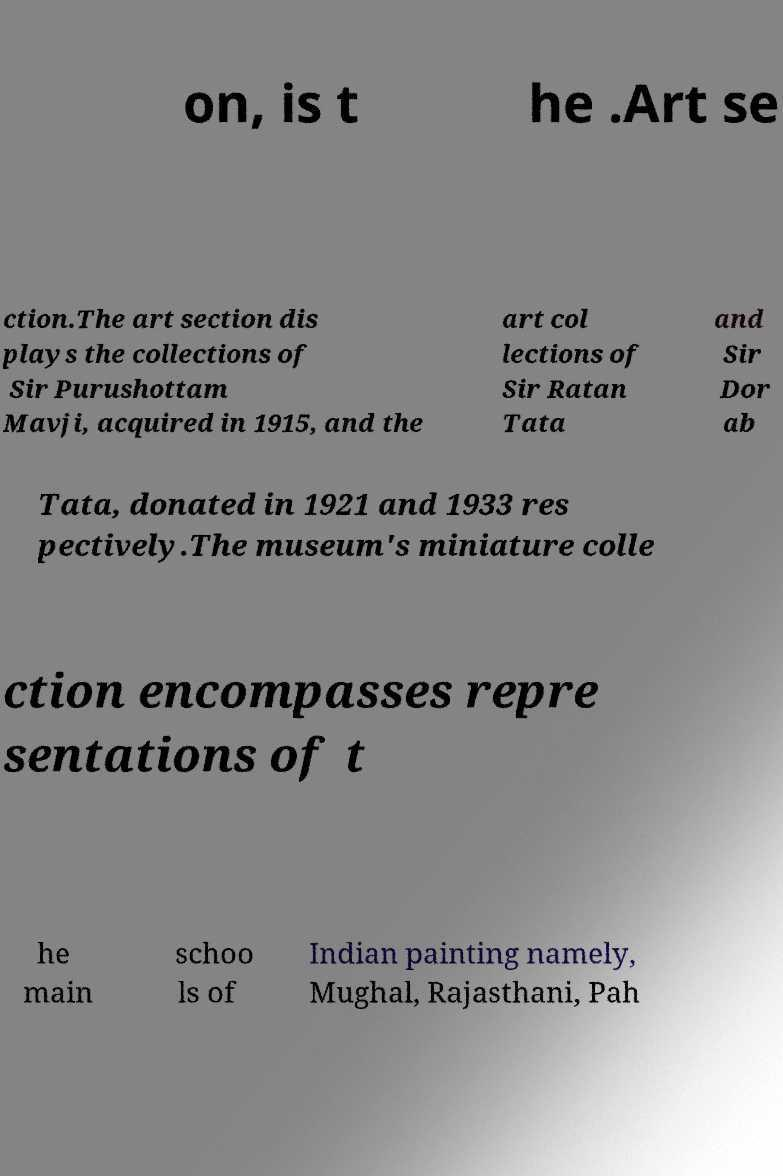Please identify and transcribe the text found in this image. on, is t he .Art se ction.The art section dis plays the collections of Sir Purushottam Mavji, acquired in 1915, and the art col lections of Sir Ratan Tata and Sir Dor ab Tata, donated in 1921 and 1933 res pectively.The museum's miniature colle ction encompasses repre sentations of t he main schoo ls of Indian painting namely, Mughal, Rajasthani, Pah 